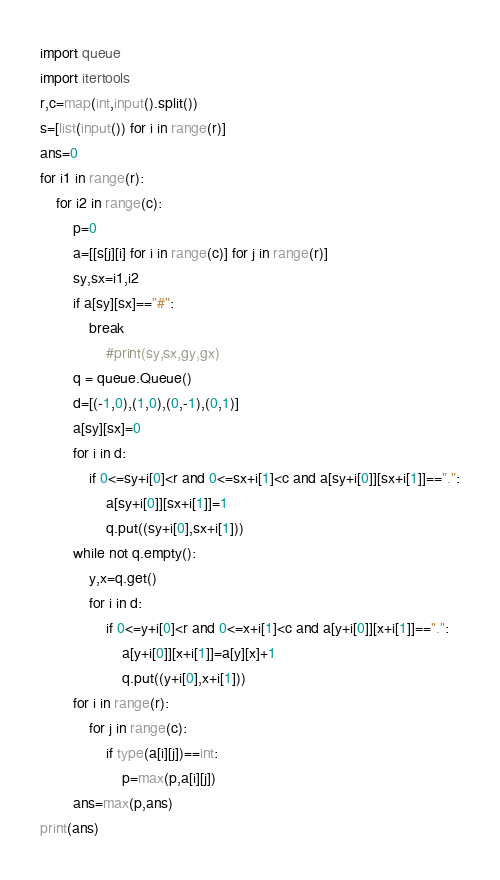<code> <loc_0><loc_0><loc_500><loc_500><_Python_>import queue
import itertools
r,c=map(int,input().split())
s=[list(input()) for i in range(r)]
ans=0
for i1 in range(r):
    for i2 in range(c):
        p=0
        a=[[s[j][i] for i in range(c)] for j in range(r)]
        sy,sx=i1,i2
        if a[sy][sx]=="#":
            break
                #print(sy,sx,gy,gx)
        q = queue.Queue()
        d=[(-1,0),(1,0),(0,-1),(0,1)]
        a[sy][sx]=0
        for i in d:
            if 0<=sy+i[0]<r and 0<=sx+i[1]<c and a[sy+i[0]][sx+i[1]]==".":
                a[sy+i[0]][sx+i[1]]=1
                q.put((sy+i[0],sx+i[1]))
        while not q.empty():
            y,x=q.get()
            for i in d:
                if 0<=y+i[0]<r and 0<=x+i[1]<c and a[y+i[0]][x+i[1]]==".":
                    a[y+i[0]][x+i[1]]=a[y][x]+1
                    q.put((y+i[0],x+i[1]))
        for i in range(r):
            for j in range(c):
                if type(a[i][j])==int:
                    p=max(p,a[i][j])
        ans=max(p,ans)
print(ans)

</code> 